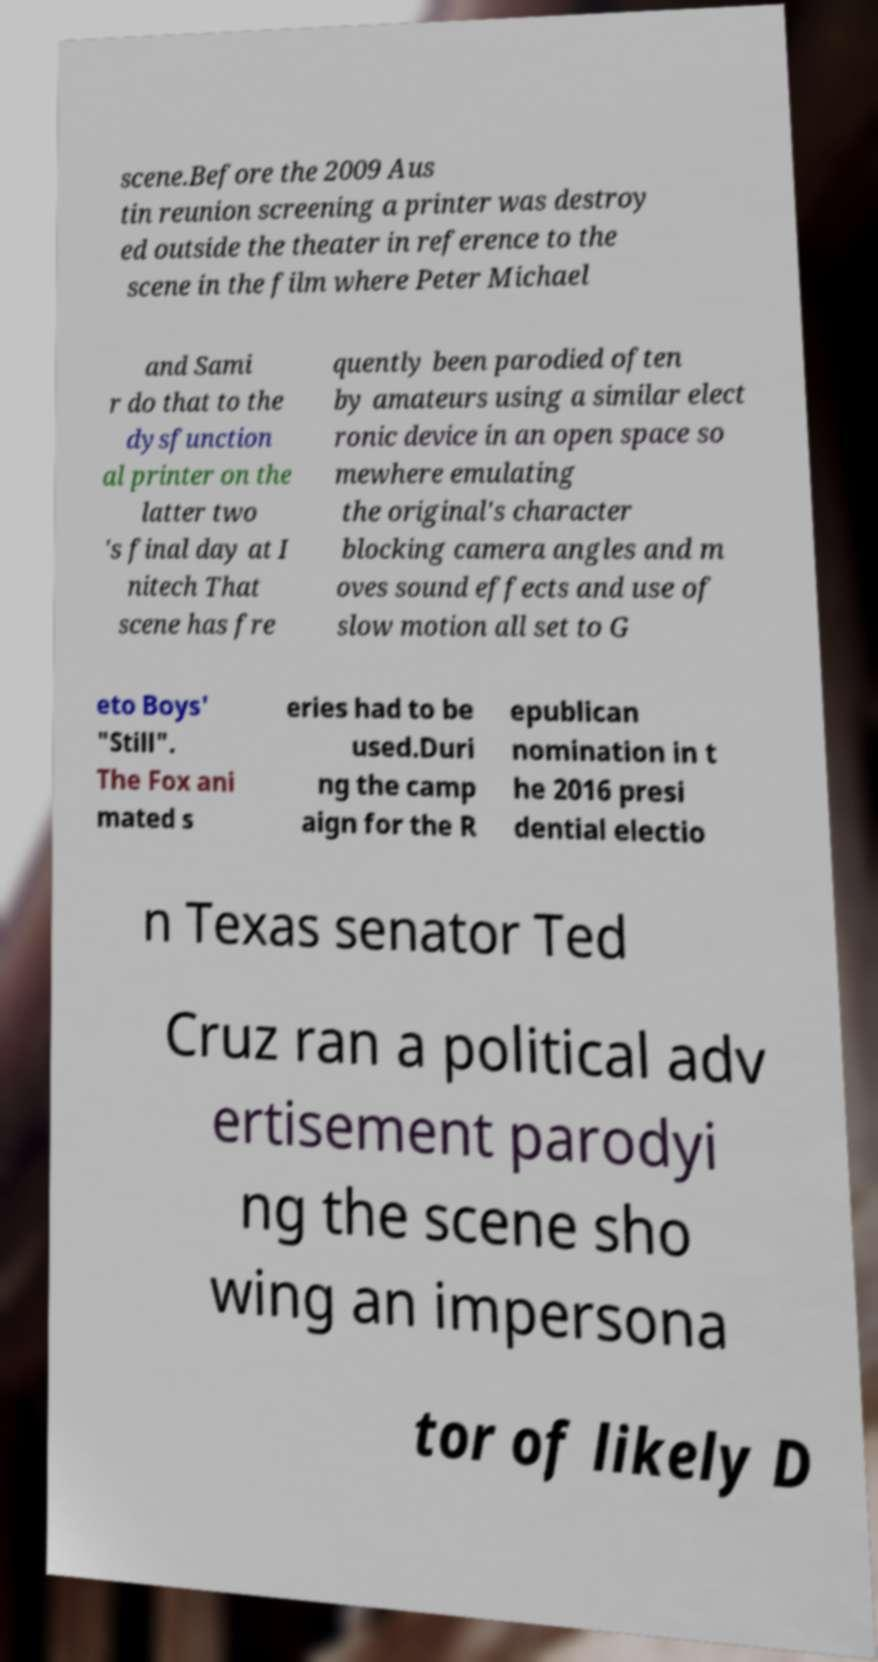Could you assist in decoding the text presented in this image and type it out clearly? scene.Before the 2009 Aus tin reunion screening a printer was destroy ed outside the theater in reference to the scene in the film where Peter Michael and Sami r do that to the dysfunction al printer on the latter two 's final day at I nitech That scene has fre quently been parodied often by amateurs using a similar elect ronic device in an open space so mewhere emulating the original's character blocking camera angles and m oves sound effects and use of slow motion all set to G eto Boys' "Still". The Fox ani mated s eries had to be used.Duri ng the camp aign for the R epublican nomination in t he 2016 presi dential electio n Texas senator Ted Cruz ran a political adv ertisement parodyi ng the scene sho wing an impersona tor of likely D 